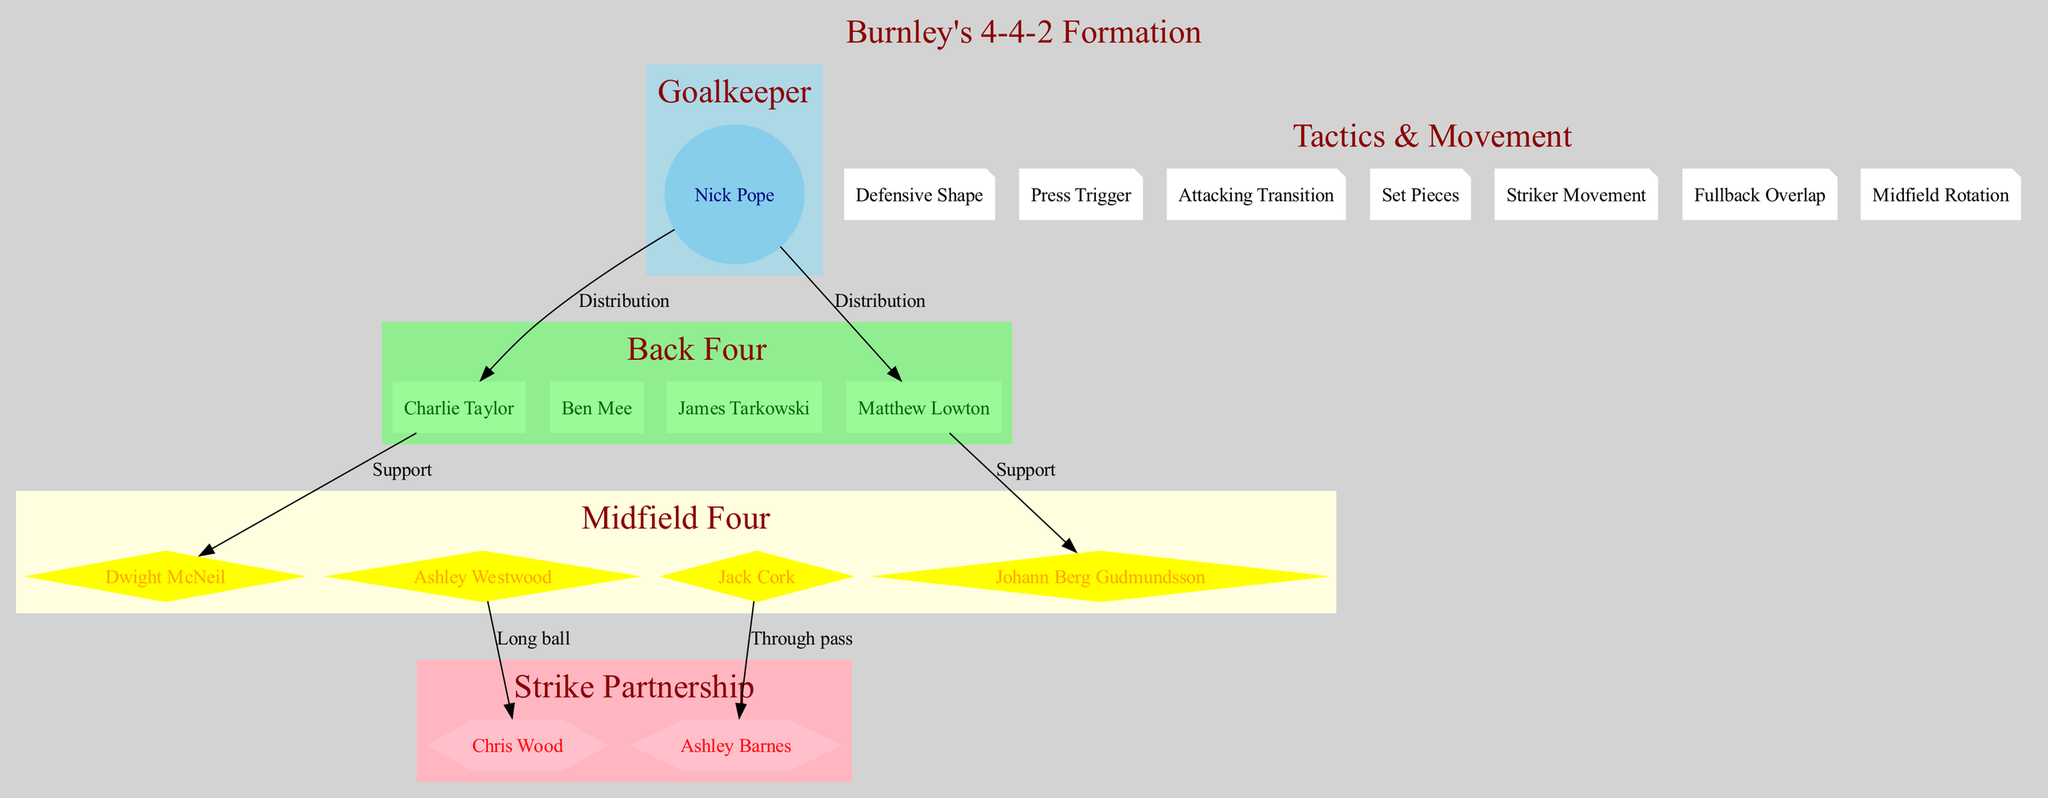What is the main formation used by Burnley? The diagram explicitly states the main formation at the top as "4-4-2".
Answer: 4-4-2 Who is the goalkeeper in this formation? The goalkeeper node shows "Nick Pope" as the player occupying that position.
Answer: Nick Pope What style do the back four utilize? The back four node indicates their style is described as a "Compact defensive line".
Answer: Compact defensive line Which two players are in the strike partnership? The strike partnership node lists "Chris Wood" and "Ashley Barnes" as the players in that role.
Answer: Chris Wood, Ashley Barnes What is the press trigger for Burnley's tactics? The tactics section includes "Opposition enters middle third" as the specified press trigger.
Answer: Opposition enters middle third How many players are in the midfield four? The midfield four node contains four players, namely "Dwight McNeil", "Ashley Westwood", "Jack Cork", and "Johann Berg Gudmundsson".
Answer: 4 What is the purpose of the striker movement pattern? The movement pattern explicitly describes that "One drops deep, one stretches defense" as the strategy for the strikers.
Answer: One drops deep, one stretches defense How are the fullbacks utilized in this formation? The diagram shows that the fullbacks engage in "Selective forward runs to provide width".
Answer: Selective forward runs to provide width Which player is responsible for long balls to Chris Wood? The diagram indicates that "Ashley Westwood" is the player who provides long balls to the striker, Chris Wood.
Answer: Ashley Westwood What is the emphasis during set pieces according to the tactics? The tactics section states that there is an "Emphasis on dead-ball situations" for set pieces.
Answer: Emphasis on dead-ball situations 